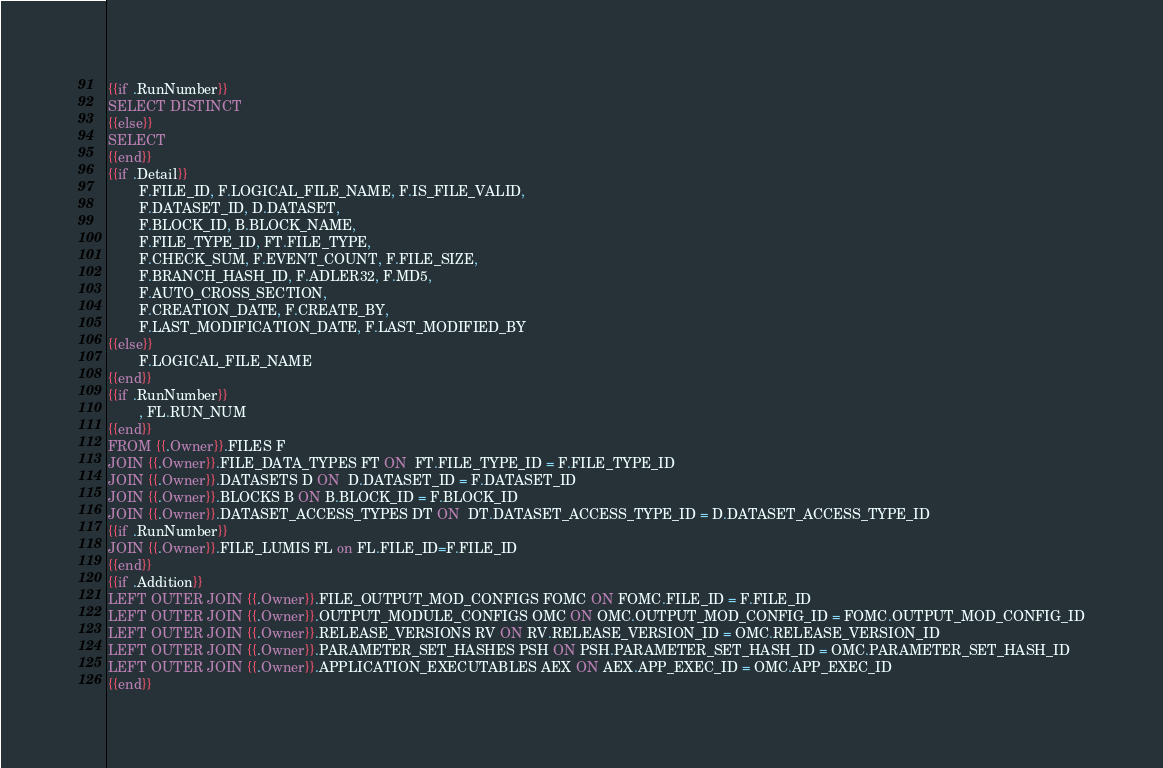Convert code to text. <code><loc_0><loc_0><loc_500><loc_500><_SQL_>{{if .RunNumber}}
SELECT DISTINCT
{{else}}
SELECT 
{{end}}
{{if .Detail}}
        F.FILE_ID, F.LOGICAL_FILE_NAME, F.IS_FILE_VALID,
        F.DATASET_ID, D.DATASET,
        F.BLOCK_ID, B.BLOCK_NAME,
        F.FILE_TYPE_ID, FT.FILE_TYPE,
        F.CHECK_SUM, F.EVENT_COUNT, F.FILE_SIZE,
        F.BRANCH_HASH_ID, F.ADLER32, F.MD5,
        F.AUTO_CROSS_SECTION,
        F.CREATION_DATE, F.CREATE_BY,
        F.LAST_MODIFICATION_DATE, F.LAST_MODIFIED_BY
{{else}}
        F.LOGICAL_FILE_NAME
{{end}}
{{if .RunNumber}}
        , FL.RUN_NUM
{{end}}
FROM {{.Owner}}.FILES F
JOIN {{.Owner}}.FILE_DATA_TYPES FT ON  FT.FILE_TYPE_ID = F.FILE_TYPE_ID
JOIN {{.Owner}}.DATASETS D ON  D.DATASET_ID = F.DATASET_ID
JOIN {{.Owner}}.BLOCKS B ON B.BLOCK_ID = F.BLOCK_ID
JOIN {{.Owner}}.DATASET_ACCESS_TYPES DT ON  DT.DATASET_ACCESS_TYPE_ID = D.DATASET_ACCESS_TYPE_ID
{{if .RunNumber}}
JOIN {{.Owner}}.FILE_LUMIS FL on FL.FILE_ID=F.FILE_ID
{{end}}
{{if .Addition}}
LEFT OUTER JOIN {{.Owner}}.FILE_OUTPUT_MOD_CONFIGS FOMC ON FOMC.FILE_ID = F.FILE_ID
LEFT OUTER JOIN {{.Owner}}.OUTPUT_MODULE_CONFIGS OMC ON OMC.OUTPUT_MOD_CONFIG_ID = FOMC.OUTPUT_MOD_CONFIG_ID
LEFT OUTER JOIN {{.Owner}}.RELEASE_VERSIONS RV ON RV.RELEASE_VERSION_ID = OMC.RELEASE_VERSION_ID
LEFT OUTER JOIN {{.Owner}}.PARAMETER_SET_HASHES PSH ON PSH.PARAMETER_SET_HASH_ID = OMC.PARAMETER_SET_HASH_ID
LEFT OUTER JOIN {{.Owner}}.APPLICATION_EXECUTABLES AEX ON AEX.APP_EXEC_ID = OMC.APP_EXEC_ID
{{end}}
</code> 